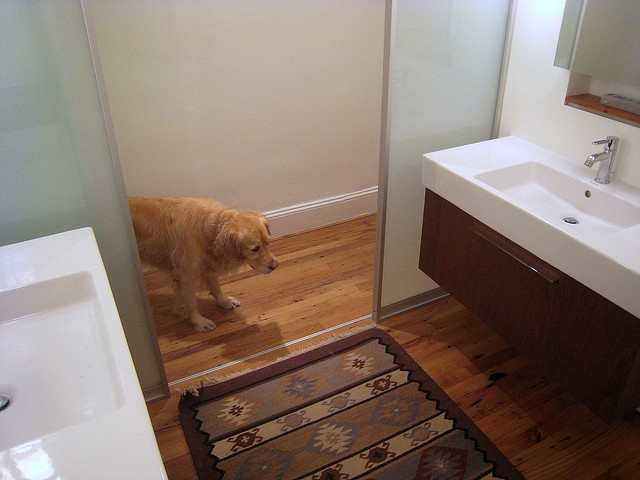Describe the objects in this image and their specific colors. I can see sink in darkgray and lightgray tones, sink in darkgray, lightgray, and gray tones, and dog in darkgray, maroon, brown, and gray tones in this image. 